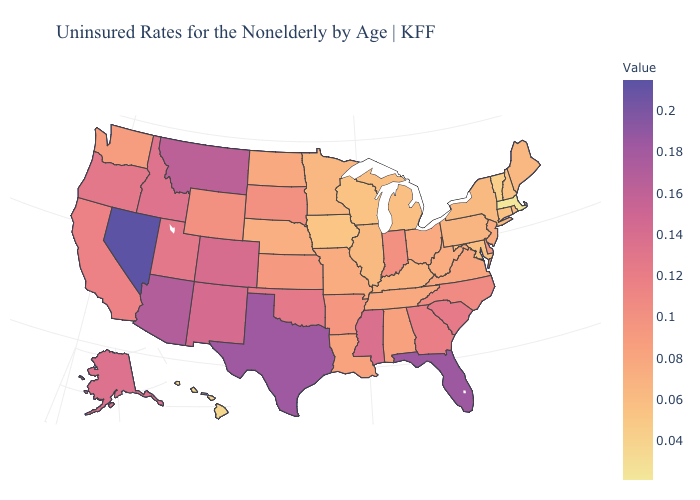Does Louisiana have a higher value than Arizona?
Quick response, please. No. Does the map have missing data?
Write a very short answer. No. Does the map have missing data?
Answer briefly. No. Among the states that border Nevada , does Utah have the highest value?
Concise answer only. No. 